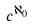<formula> <loc_0><loc_0><loc_500><loc_500>c ^ { \aleph _ { 0 } }</formula> 